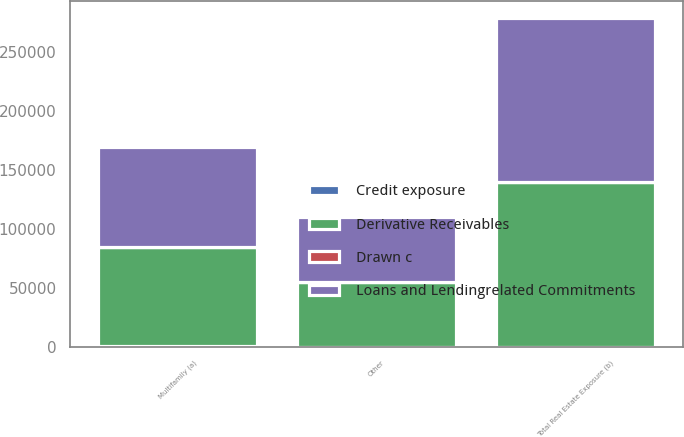Convert chart. <chart><loc_0><loc_0><loc_500><loc_500><stacked_bar_chart><ecel><fcel>Multifamily (a)<fcel>Other<fcel>Total Real Estate Exposure (b)<nl><fcel>Loans and Lendingrelated Commitments<fcel>84635<fcel>54620<fcel>139255<nl><fcel>Drawn c<fcel>34<fcel>120<fcel>154<nl><fcel>Derivative Receivables<fcel>84669<fcel>54740<fcel>139409<nl><fcel>Credit exposure<fcel>89<fcel>74<fcel>83<nl></chart> 